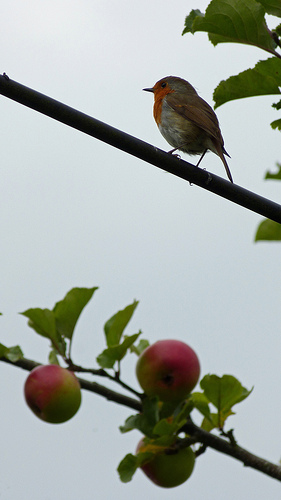How many apples are there? There are three apples visible in the image, hanging from the branches of what appears to be an apple tree, with varying shades of red and green, suggesting different stages of ripeness. 